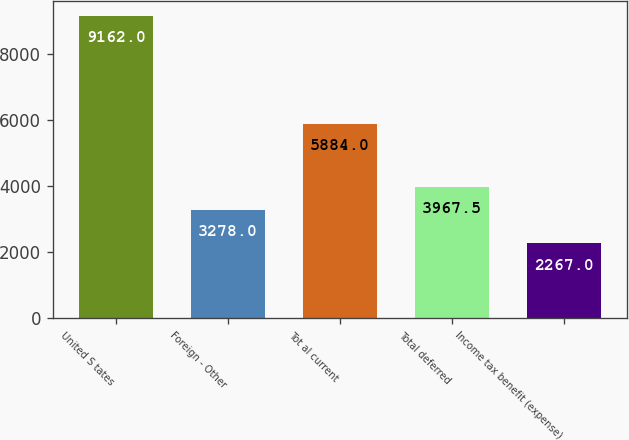Convert chart. <chart><loc_0><loc_0><loc_500><loc_500><bar_chart><fcel>United S tates<fcel>Foreign - Other<fcel>Tot al current<fcel>Total deferred<fcel>Income tax benefit (expense)<nl><fcel>9162<fcel>3278<fcel>5884<fcel>3967.5<fcel>2267<nl></chart> 